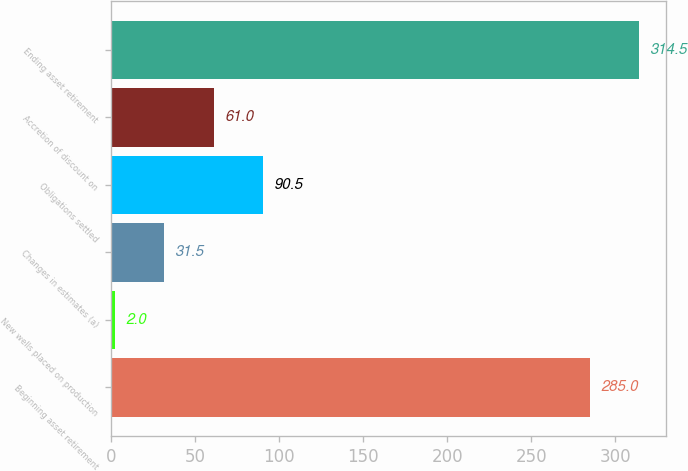Convert chart. <chart><loc_0><loc_0><loc_500><loc_500><bar_chart><fcel>Beginning asset retirement<fcel>New wells placed on production<fcel>Changes in estimates (a)<fcel>Obligations settled<fcel>Accretion of discount on<fcel>Ending asset retirement<nl><fcel>285<fcel>2<fcel>31.5<fcel>90.5<fcel>61<fcel>314.5<nl></chart> 